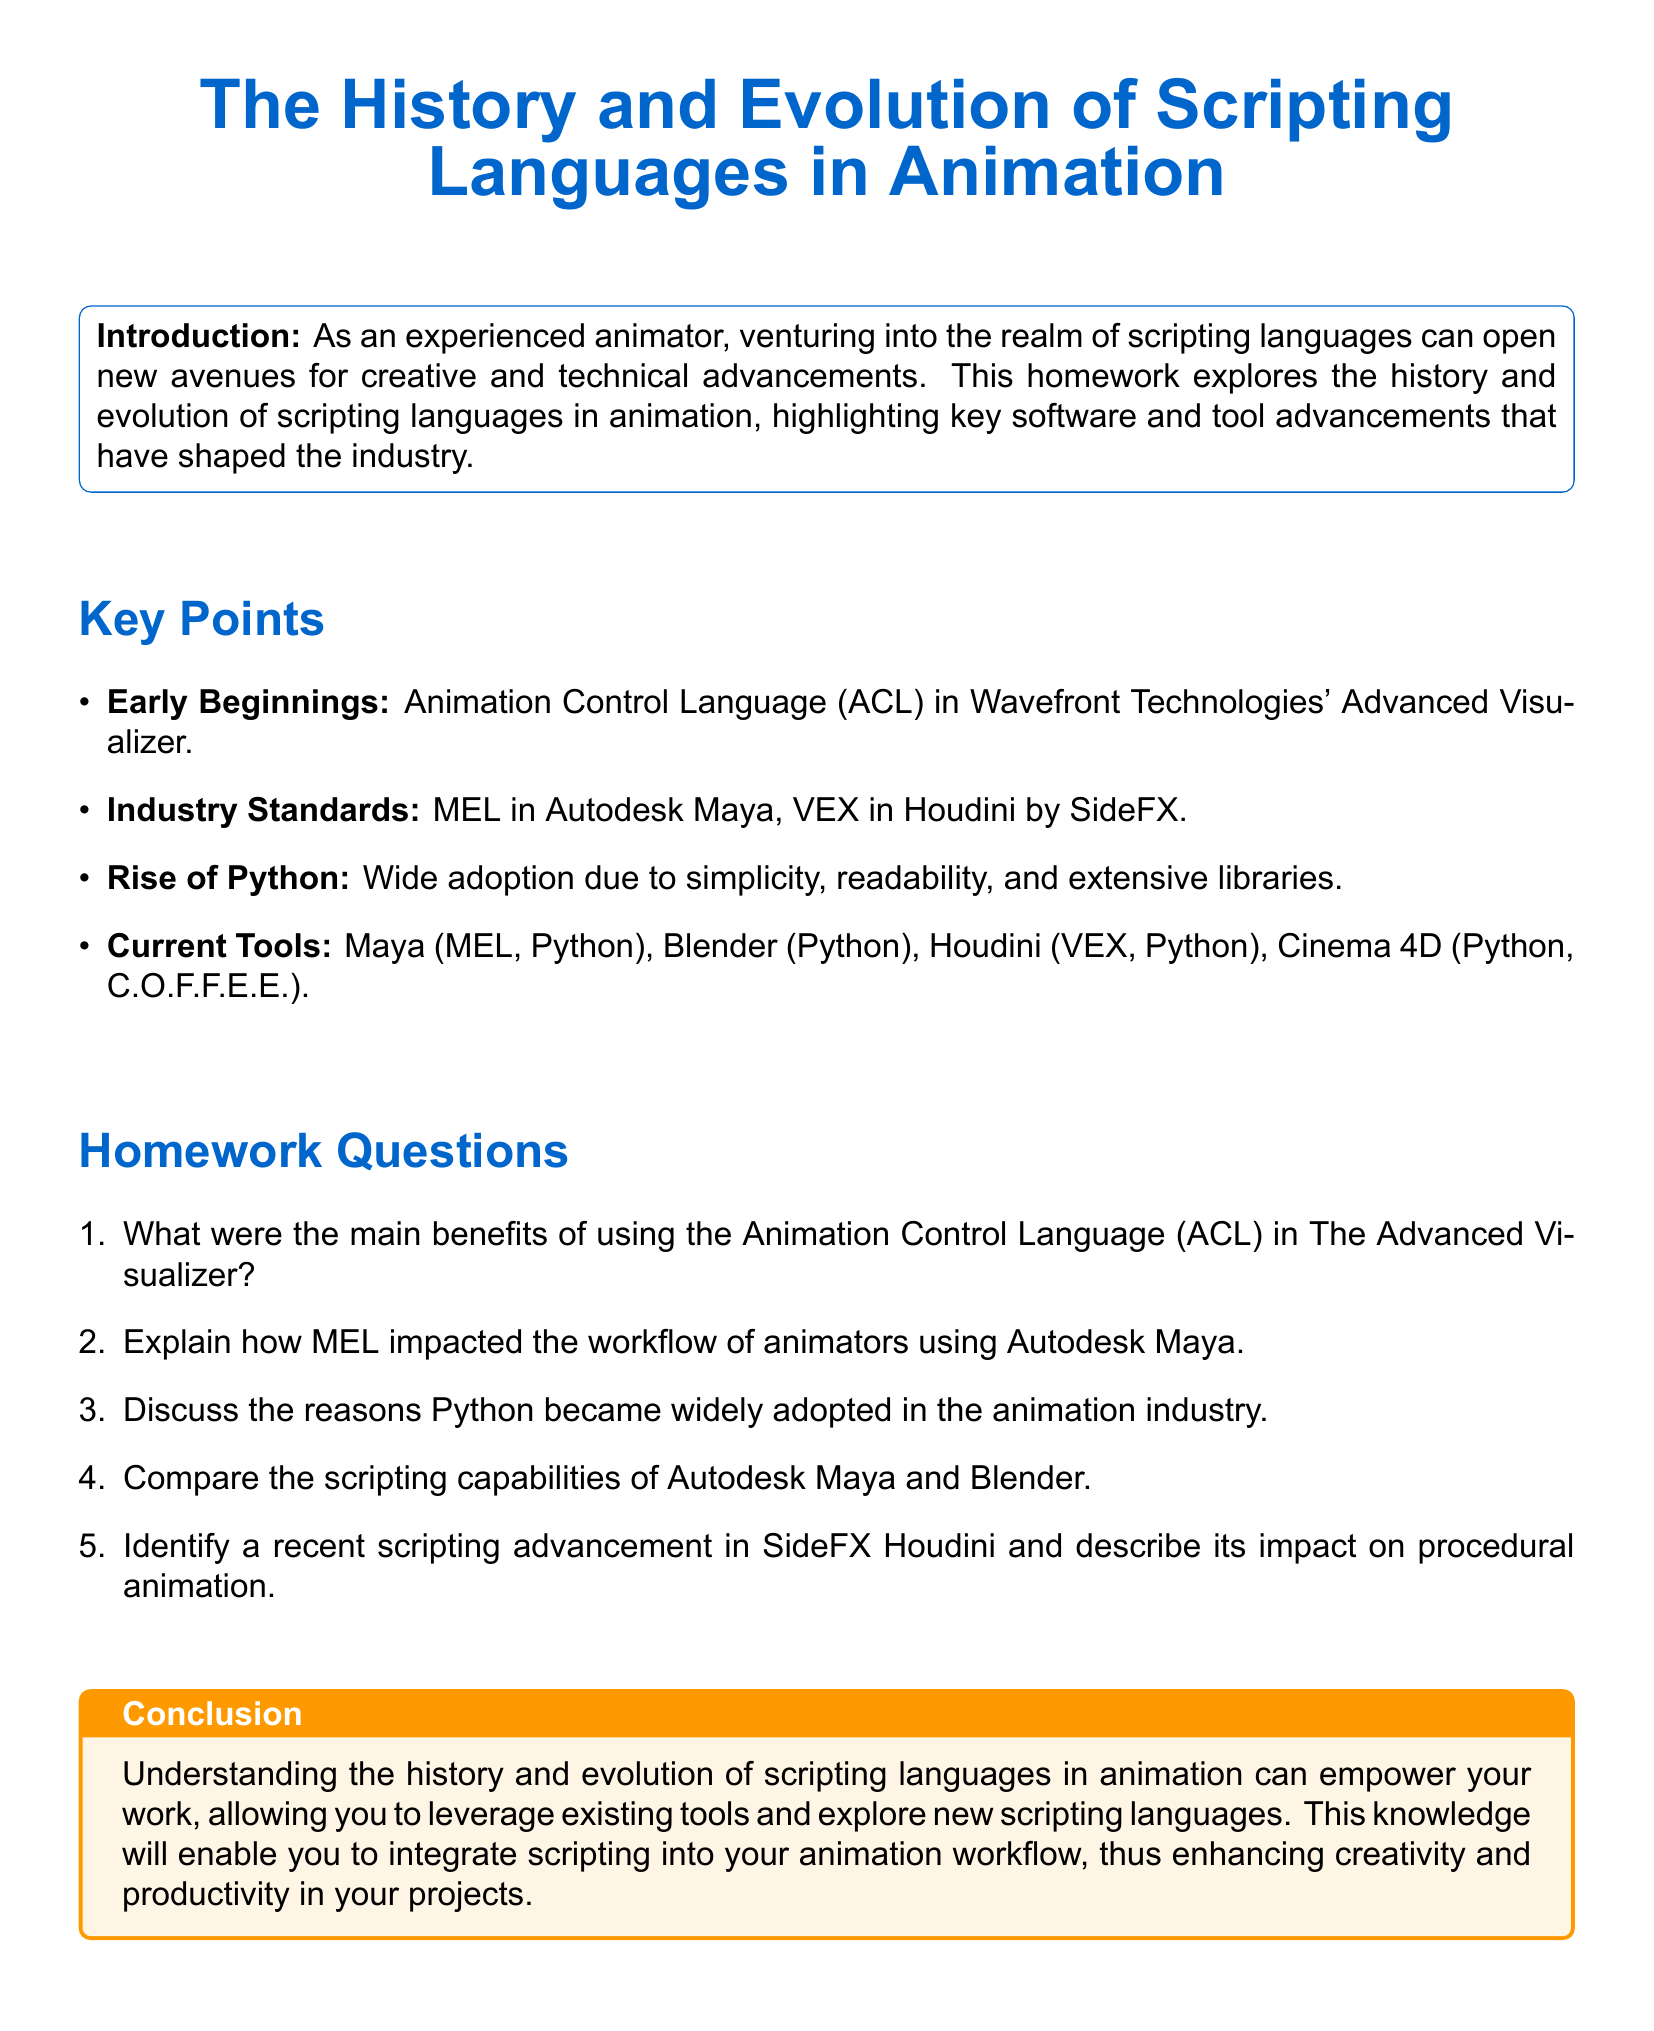What was the first scripting language mentioned in the document? The document mentions the Animation Control Language (ACL) as the first scripting language used in animation.
Answer: Animation Control Language (ACL) Which software utilized the Animation Control Language? The document states that the Animation Control Language was used in Wavefront Technologies' Advanced Visualizer.
Answer: Wavefront Technologies' Advanced Visualizer What scripting language is associated with Autodesk Maya? According to the document, MEL is associated with Autodesk Maya.
Answer: MEL What programming language gained wide adoption in the animation industry? The document highlights Python as the programming language that gained wide adoption due to its simplicity and readability.
Answer: Python Which two programming languages are mentioned in relation to Houdini? The document lists VEX and Python as the programming languages associated with SideFX Houdini.
Answer: VEX, Python What is one recent scripting advancement mentioned for SideFX Houdini? The document prompts for a recent scripting advancement in SideFX Houdini without specifying one, which requires further exploration of the subject.
Answer: [Open-ended] How many key software tools were listed in the document? The document provides a total of four key software tools that utilize scripting languages for animation.
Answer: Four What does the document suggest can empower an animator's work? It suggests that understanding the history and evolution of scripting languages in animation can empower an animator's work.
Answer: Understanding scripting languages Which tool incorporates C.O.F.F.E.E. as a scripting language? According to the document, Cinema 4D incorporates C.O.F.F.E.E. as a scripting language.
Answer: Cinema 4D What does MEL stand for? The document mentions MEL without an expanded form and requires some background knowledge, or it can be accepted as is.
Answer: [Open-ended] 